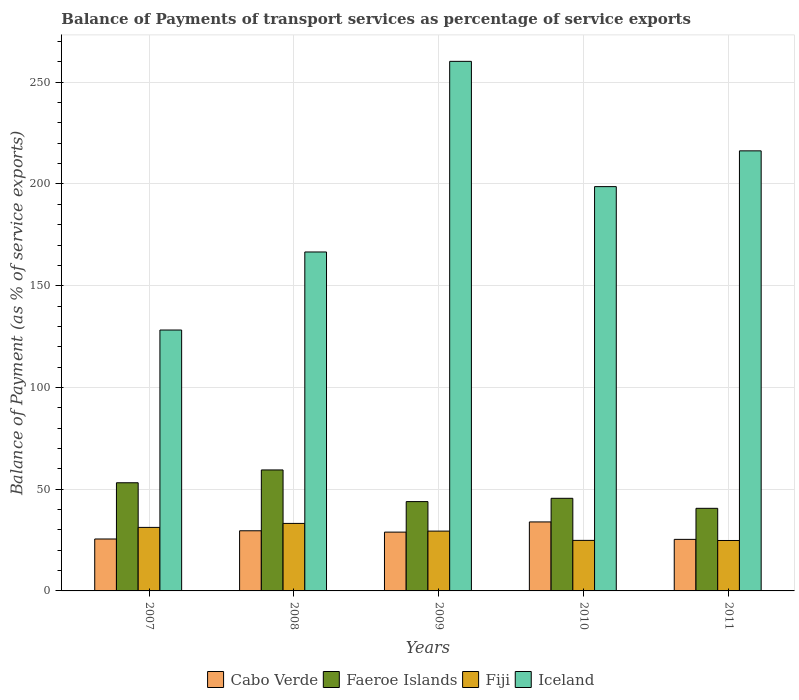How many groups of bars are there?
Offer a terse response. 5. Are the number of bars on each tick of the X-axis equal?
Offer a terse response. Yes. How many bars are there on the 1st tick from the right?
Offer a terse response. 4. What is the label of the 1st group of bars from the left?
Make the answer very short. 2007. What is the balance of payments of transport services in Fiji in 2010?
Offer a very short reply. 24.84. Across all years, what is the maximum balance of payments of transport services in Cabo Verde?
Offer a terse response. 33.91. Across all years, what is the minimum balance of payments of transport services in Cabo Verde?
Give a very brief answer. 25.34. In which year was the balance of payments of transport services in Cabo Verde maximum?
Provide a succinct answer. 2010. What is the total balance of payments of transport services in Faeroe Islands in the graph?
Ensure brevity in your answer.  242.63. What is the difference between the balance of payments of transport services in Fiji in 2008 and that in 2011?
Give a very brief answer. 8.39. What is the difference between the balance of payments of transport services in Cabo Verde in 2008 and the balance of payments of transport services in Fiji in 2010?
Provide a short and direct response. 4.72. What is the average balance of payments of transport services in Iceland per year?
Ensure brevity in your answer.  194.01. In the year 2010, what is the difference between the balance of payments of transport services in Fiji and balance of payments of transport services in Cabo Verde?
Your answer should be compact. -9.07. In how many years, is the balance of payments of transport services in Cabo Verde greater than 180 %?
Your answer should be compact. 0. What is the ratio of the balance of payments of transport services in Cabo Verde in 2008 to that in 2009?
Your answer should be very brief. 1.02. Is the difference between the balance of payments of transport services in Fiji in 2007 and 2009 greater than the difference between the balance of payments of transport services in Cabo Verde in 2007 and 2009?
Offer a terse response. Yes. What is the difference between the highest and the second highest balance of payments of transport services in Iceland?
Your answer should be compact. 43.99. What is the difference between the highest and the lowest balance of payments of transport services in Faeroe Islands?
Offer a terse response. 18.86. Is it the case that in every year, the sum of the balance of payments of transport services in Iceland and balance of payments of transport services in Fiji is greater than the sum of balance of payments of transport services in Faeroe Islands and balance of payments of transport services in Cabo Verde?
Your answer should be compact. Yes. What does the 3rd bar from the left in 2010 represents?
Ensure brevity in your answer.  Fiji. What does the 1st bar from the right in 2007 represents?
Your answer should be compact. Iceland. How many bars are there?
Give a very brief answer. 20. Are all the bars in the graph horizontal?
Give a very brief answer. No. How many years are there in the graph?
Provide a short and direct response. 5. Where does the legend appear in the graph?
Provide a short and direct response. Bottom center. What is the title of the graph?
Make the answer very short. Balance of Payments of transport services as percentage of service exports. What is the label or title of the X-axis?
Provide a succinct answer. Years. What is the label or title of the Y-axis?
Make the answer very short. Balance of Payment (as % of service exports). What is the Balance of Payment (as % of service exports) of Cabo Verde in 2007?
Your answer should be very brief. 25.53. What is the Balance of Payment (as % of service exports) in Faeroe Islands in 2007?
Provide a short and direct response. 53.16. What is the Balance of Payment (as % of service exports) in Fiji in 2007?
Offer a very short reply. 31.22. What is the Balance of Payment (as % of service exports) in Iceland in 2007?
Offer a very short reply. 128.23. What is the Balance of Payment (as % of service exports) of Cabo Verde in 2008?
Keep it short and to the point. 29.56. What is the Balance of Payment (as % of service exports) of Faeroe Islands in 2008?
Offer a terse response. 59.46. What is the Balance of Payment (as % of service exports) of Fiji in 2008?
Keep it short and to the point. 33.18. What is the Balance of Payment (as % of service exports) of Iceland in 2008?
Keep it short and to the point. 166.58. What is the Balance of Payment (as % of service exports) of Cabo Verde in 2009?
Make the answer very short. 28.9. What is the Balance of Payment (as % of service exports) in Faeroe Islands in 2009?
Your answer should be compact. 43.9. What is the Balance of Payment (as % of service exports) in Fiji in 2009?
Your answer should be very brief. 29.4. What is the Balance of Payment (as % of service exports) of Iceland in 2009?
Make the answer very short. 260.27. What is the Balance of Payment (as % of service exports) in Cabo Verde in 2010?
Your response must be concise. 33.91. What is the Balance of Payment (as % of service exports) of Faeroe Islands in 2010?
Keep it short and to the point. 45.52. What is the Balance of Payment (as % of service exports) of Fiji in 2010?
Your answer should be compact. 24.84. What is the Balance of Payment (as % of service exports) in Iceland in 2010?
Give a very brief answer. 198.71. What is the Balance of Payment (as % of service exports) in Cabo Verde in 2011?
Offer a terse response. 25.34. What is the Balance of Payment (as % of service exports) in Faeroe Islands in 2011?
Ensure brevity in your answer.  40.59. What is the Balance of Payment (as % of service exports) of Fiji in 2011?
Give a very brief answer. 24.79. What is the Balance of Payment (as % of service exports) of Iceland in 2011?
Provide a succinct answer. 216.28. Across all years, what is the maximum Balance of Payment (as % of service exports) of Cabo Verde?
Provide a short and direct response. 33.91. Across all years, what is the maximum Balance of Payment (as % of service exports) in Faeroe Islands?
Make the answer very short. 59.46. Across all years, what is the maximum Balance of Payment (as % of service exports) of Fiji?
Give a very brief answer. 33.18. Across all years, what is the maximum Balance of Payment (as % of service exports) in Iceland?
Ensure brevity in your answer.  260.27. Across all years, what is the minimum Balance of Payment (as % of service exports) in Cabo Verde?
Your answer should be compact. 25.34. Across all years, what is the minimum Balance of Payment (as % of service exports) in Faeroe Islands?
Ensure brevity in your answer.  40.59. Across all years, what is the minimum Balance of Payment (as % of service exports) of Fiji?
Give a very brief answer. 24.79. Across all years, what is the minimum Balance of Payment (as % of service exports) of Iceland?
Provide a succinct answer. 128.23. What is the total Balance of Payment (as % of service exports) of Cabo Verde in the graph?
Offer a very short reply. 143.24. What is the total Balance of Payment (as % of service exports) in Faeroe Islands in the graph?
Ensure brevity in your answer.  242.63. What is the total Balance of Payment (as % of service exports) of Fiji in the graph?
Your response must be concise. 143.42. What is the total Balance of Payment (as % of service exports) in Iceland in the graph?
Make the answer very short. 970.07. What is the difference between the Balance of Payment (as % of service exports) in Cabo Verde in 2007 and that in 2008?
Ensure brevity in your answer.  -4.03. What is the difference between the Balance of Payment (as % of service exports) in Faeroe Islands in 2007 and that in 2008?
Give a very brief answer. -6.3. What is the difference between the Balance of Payment (as % of service exports) of Fiji in 2007 and that in 2008?
Your response must be concise. -1.95. What is the difference between the Balance of Payment (as % of service exports) of Iceland in 2007 and that in 2008?
Keep it short and to the point. -38.35. What is the difference between the Balance of Payment (as % of service exports) in Cabo Verde in 2007 and that in 2009?
Your response must be concise. -3.38. What is the difference between the Balance of Payment (as % of service exports) in Faeroe Islands in 2007 and that in 2009?
Ensure brevity in your answer.  9.26. What is the difference between the Balance of Payment (as % of service exports) in Fiji in 2007 and that in 2009?
Provide a short and direct response. 1.82. What is the difference between the Balance of Payment (as % of service exports) in Iceland in 2007 and that in 2009?
Keep it short and to the point. -132.04. What is the difference between the Balance of Payment (as % of service exports) of Cabo Verde in 2007 and that in 2010?
Make the answer very short. -8.38. What is the difference between the Balance of Payment (as % of service exports) in Faeroe Islands in 2007 and that in 2010?
Keep it short and to the point. 7.64. What is the difference between the Balance of Payment (as % of service exports) in Fiji in 2007 and that in 2010?
Make the answer very short. 6.39. What is the difference between the Balance of Payment (as % of service exports) in Iceland in 2007 and that in 2010?
Make the answer very short. -70.48. What is the difference between the Balance of Payment (as % of service exports) in Cabo Verde in 2007 and that in 2011?
Offer a terse response. 0.18. What is the difference between the Balance of Payment (as % of service exports) in Faeroe Islands in 2007 and that in 2011?
Provide a succinct answer. 12.57. What is the difference between the Balance of Payment (as % of service exports) of Fiji in 2007 and that in 2011?
Your answer should be very brief. 6.44. What is the difference between the Balance of Payment (as % of service exports) of Iceland in 2007 and that in 2011?
Your answer should be very brief. -88.05. What is the difference between the Balance of Payment (as % of service exports) of Cabo Verde in 2008 and that in 2009?
Keep it short and to the point. 0.66. What is the difference between the Balance of Payment (as % of service exports) of Faeroe Islands in 2008 and that in 2009?
Give a very brief answer. 15.56. What is the difference between the Balance of Payment (as % of service exports) of Fiji in 2008 and that in 2009?
Give a very brief answer. 3.77. What is the difference between the Balance of Payment (as % of service exports) of Iceland in 2008 and that in 2009?
Provide a short and direct response. -93.69. What is the difference between the Balance of Payment (as % of service exports) in Cabo Verde in 2008 and that in 2010?
Keep it short and to the point. -4.35. What is the difference between the Balance of Payment (as % of service exports) of Faeroe Islands in 2008 and that in 2010?
Make the answer very short. 13.94. What is the difference between the Balance of Payment (as % of service exports) in Fiji in 2008 and that in 2010?
Offer a very short reply. 8.34. What is the difference between the Balance of Payment (as % of service exports) in Iceland in 2008 and that in 2010?
Your response must be concise. -32.13. What is the difference between the Balance of Payment (as % of service exports) in Cabo Verde in 2008 and that in 2011?
Ensure brevity in your answer.  4.22. What is the difference between the Balance of Payment (as % of service exports) of Faeroe Islands in 2008 and that in 2011?
Your answer should be very brief. 18.86. What is the difference between the Balance of Payment (as % of service exports) in Fiji in 2008 and that in 2011?
Make the answer very short. 8.39. What is the difference between the Balance of Payment (as % of service exports) of Iceland in 2008 and that in 2011?
Give a very brief answer. -49.7. What is the difference between the Balance of Payment (as % of service exports) of Cabo Verde in 2009 and that in 2010?
Keep it short and to the point. -5.01. What is the difference between the Balance of Payment (as % of service exports) of Faeroe Islands in 2009 and that in 2010?
Your response must be concise. -1.62. What is the difference between the Balance of Payment (as % of service exports) in Fiji in 2009 and that in 2010?
Your answer should be very brief. 4.57. What is the difference between the Balance of Payment (as % of service exports) in Iceland in 2009 and that in 2010?
Offer a terse response. 61.56. What is the difference between the Balance of Payment (as % of service exports) in Cabo Verde in 2009 and that in 2011?
Your answer should be compact. 3.56. What is the difference between the Balance of Payment (as % of service exports) in Faeroe Islands in 2009 and that in 2011?
Your response must be concise. 3.31. What is the difference between the Balance of Payment (as % of service exports) in Fiji in 2009 and that in 2011?
Offer a terse response. 4.62. What is the difference between the Balance of Payment (as % of service exports) of Iceland in 2009 and that in 2011?
Offer a terse response. 43.99. What is the difference between the Balance of Payment (as % of service exports) in Cabo Verde in 2010 and that in 2011?
Provide a succinct answer. 8.57. What is the difference between the Balance of Payment (as % of service exports) of Faeroe Islands in 2010 and that in 2011?
Provide a succinct answer. 4.92. What is the difference between the Balance of Payment (as % of service exports) in Fiji in 2010 and that in 2011?
Give a very brief answer. 0.05. What is the difference between the Balance of Payment (as % of service exports) in Iceland in 2010 and that in 2011?
Make the answer very short. -17.57. What is the difference between the Balance of Payment (as % of service exports) in Cabo Verde in 2007 and the Balance of Payment (as % of service exports) in Faeroe Islands in 2008?
Your response must be concise. -33.93. What is the difference between the Balance of Payment (as % of service exports) in Cabo Verde in 2007 and the Balance of Payment (as % of service exports) in Fiji in 2008?
Your answer should be very brief. -7.65. What is the difference between the Balance of Payment (as % of service exports) of Cabo Verde in 2007 and the Balance of Payment (as % of service exports) of Iceland in 2008?
Offer a very short reply. -141.06. What is the difference between the Balance of Payment (as % of service exports) in Faeroe Islands in 2007 and the Balance of Payment (as % of service exports) in Fiji in 2008?
Give a very brief answer. 19.98. What is the difference between the Balance of Payment (as % of service exports) of Faeroe Islands in 2007 and the Balance of Payment (as % of service exports) of Iceland in 2008?
Your answer should be very brief. -113.42. What is the difference between the Balance of Payment (as % of service exports) in Fiji in 2007 and the Balance of Payment (as % of service exports) in Iceland in 2008?
Make the answer very short. -135.36. What is the difference between the Balance of Payment (as % of service exports) in Cabo Verde in 2007 and the Balance of Payment (as % of service exports) in Faeroe Islands in 2009?
Offer a terse response. -18.38. What is the difference between the Balance of Payment (as % of service exports) in Cabo Verde in 2007 and the Balance of Payment (as % of service exports) in Fiji in 2009?
Make the answer very short. -3.88. What is the difference between the Balance of Payment (as % of service exports) in Cabo Verde in 2007 and the Balance of Payment (as % of service exports) in Iceland in 2009?
Make the answer very short. -234.74. What is the difference between the Balance of Payment (as % of service exports) in Faeroe Islands in 2007 and the Balance of Payment (as % of service exports) in Fiji in 2009?
Your response must be concise. 23.76. What is the difference between the Balance of Payment (as % of service exports) of Faeroe Islands in 2007 and the Balance of Payment (as % of service exports) of Iceland in 2009?
Ensure brevity in your answer.  -207.11. What is the difference between the Balance of Payment (as % of service exports) in Fiji in 2007 and the Balance of Payment (as % of service exports) in Iceland in 2009?
Give a very brief answer. -229.05. What is the difference between the Balance of Payment (as % of service exports) in Cabo Verde in 2007 and the Balance of Payment (as % of service exports) in Faeroe Islands in 2010?
Offer a very short reply. -19.99. What is the difference between the Balance of Payment (as % of service exports) in Cabo Verde in 2007 and the Balance of Payment (as % of service exports) in Fiji in 2010?
Keep it short and to the point. 0.69. What is the difference between the Balance of Payment (as % of service exports) of Cabo Verde in 2007 and the Balance of Payment (as % of service exports) of Iceland in 2010?
Make the answer very short. -173.18. What is the difference between the Balance of Payment (as % of service exports) in Faeroe Islands in 2007 and the Balance of Payment (as % of service exports) in Fiji in 2010?
Keep it short and to the point. 28.32. What is the difference between the Balance of Payment (as % of service exports) of Faeroe Islands in 2007 and the Balance of Payment (as % of service exports) of Iceland in 2010?
Ensure brevity in your answer.  -145.55. What is the difference between the Balance of Payment (as % of service exports) in Fiji in 2007 and the Balance of Payment (as % of service exports) in Iceland in 2010?
Your response must be concise. -167.48. What is the difference between the Balance of Payment (as % of service exports) in Cabo Verde in 2007 and the Balance of Payment (as % of service exports) in Faeroe Islands in 2011?
Make the answer very short. -15.07. What is the difference between the Balance of Payment (as % of service exports) in Cabo Verde in 2007 and the Balance of Payment (as % of service exports) in Fiji in 2011?
Your answer should be compact. 0.74. What is the difference between the Balance of Payment (as % of service exports) of Cabo Verde in 2007 and the Balance of Payment (as % of service exports) of Iceland in 2011?
Provide a short and direct response. -190.76. What is the difference between the Balance of Payment (as % of service exports) of Faeroe Islands in 2007 and the Balance of Payment (as % of service exports) of Fiji in 2011?
Give a very brief answer. 28.37. What is the difference between the Balance of Payment (as % of service exports) of Faeroe Islands in 2007 and the Balance of Payment (as % of service exports) of Iceland in 2011?
Keep it short and to the point. -163.12. What is the difference between the Balance of Payment (as % of service exports) of Fiji in 2007 and the Balance of Payment (as % of service exports) of Iceland in 2011?
Keep it short and to the point. -185.06. What is the difference between the Balance of Payment (as % of service exports) in Cabo Verde in 2008 and the Balance of Payment (as % of service exports) in Faeroe Islands in 2009?
Keep it short and to the point. -14.34. What is the difference between the Balance of Payment (as % of service exports) in Cabo Verde in 2008 and the Balance of Payment (as % of service exports) in Fiji in 2009?
Offer a very short reply. 0.16. What is the difference between the Balance of Payment (as % of service exports) in Cabo Verde in 2008 and the Balance of Payment (as % of service exports) in Iceland in 2009?
Your answer should be very brief. -230.71. What is the difference between the Balance of Payment (as % of service exports) of Faeroe Islands in 2008 and the Balance of Payment (as % of service exports) of Fiji in 2009?
Your answer should be compact. 30.05. What is the difference between the Balance of Payment (as % of service exports) of Faeroe Islands in 2008 and the Balance of Payment (as % of service exports) of Iceland in 2009?
Your answer should be compact. -200.81. What is the difference between the Balance of Payment (as % of service exports) in Fiji in 2008 and the Balance of Payment (as % of service exports) in Iceland in 2009?
Offer a very short reply. -227.09. What is the difference between the Balance of Payment (as % of service exports) of Cabo Verde in 2008 and the Balance of Payment (as % of service exports) of Faeroe Islands in 2010?
Keep it short and to the point. -15.96. What is the difference between the Balance of Payment (as % of service exports) in Cabo Verde in 2008 and the Balance of Payment (as % of service exports) in Fiji in 2010?
Keep it short and to the point. 4.72. What is the difference between the Balance of Payment (as % of service exports) of Cabo Verde in 2008 and the Balance of Payment (as % of service exports) of Iceland in 2010?
Provide a succinct answer. -169.15. What is the difference between the Balance of Payment (as % of service exports) in Faeroe Islands in 2008 and the Balance of Payment (as % of service exports) in Fiji in 2010?
Your response must be concise. 34.62. What is the difference between the Balance of Payment (as % of service exports) in Faeroe Islands in 2008 and the Balance of Payment (as % of service exports) in Iceland in 2010?
Provide a short and direct response. -139.25. What is the difference between the Balance of Payment (as % of service exports) of Fiji in 2008 and the Balance of Payment (as % of service exports) of Iceland in 2010?
Ensure brevity in your answer.  -165.53. What is the difference between the Balance of Payment (as % of service exports) in Cabo Verde in 2008 and the Balance of Payment (as % of service exports) in Faeroe Islands in 2011?
Offer a terse response. -11.04. What is the difference between the Balance of Payment (as % of service exports) in Cabo Verde in 2008 and the Balance of Payment (as % of service exports) in Fiji in 2011?
Your answer should be compact. 4.77. What is the difference between the Balance of Payment (as % of service exports) of Cabo Verde in 2008 and the Balance of Payment (as % of service exports) of Iceland in 2011?
Make the answer very short. -186.72. What is the difference between the Balance of Payment (as % of service exports) in Faeroe Islands in 2008 and the Balance of Payment (as % of service exports) in Fiji in 2011?
Offer a terse response. 34.67. What is the difference between the Balance of Payment (as % of service exports) of Faeroe Islands in 2008 and the Balance of Payment (as % of service exports) of Iceland in 2011?
Your answer should be compact. -156.82. What is the difference between the Balance of Payment (as % of service exports) in Fiji in 2008 and the Balance of Payment (as % of service exports) in Iceland in 2011?
Offer a terse response. -183.11. What is the difference between the Balance of Payment (as % of service exports) in Cabo Verde in 2009 and the Balance of Payment (as % of service exports) in Faeroe Islands in 2010?
Your answer should be very brief. -16.62. What is the difference between the Balance of Payment (as % of service exports) of Cabo Verde in 2009 and the Balance of Payment (as % of service exports) of Fiji in 2010?
Offer a very short reply. 4.07. What is the difference between the Balance of Payment (as % of service exports) of Cabo Verde in 2009 and the Balance of Payment (as % of service exports) of Iceland in 2010?
Your response must be concise. -169.81. What is the difference between the Balance of Payment (as % of service exports) of Faeroe Islands in 2009 and the Balance of Payment (as % of service exports) of Fiji in 2010?
Ensure brevity in your answer.  19.06. What is the difference between the Balance of Payment (as % of service exports) of Faeroe Islands in 2009 and the Balance of Payment (as % of service exports) of Iceland in 2010?
Make the answer very short. -154.81. What is the difference between the Balance of Payment (as % of service exports) of Fiji in 2009 and the Balance of Payment (as % of service exports) of Iceland in 2010?
Make the answer very short. -169.3. What is the difference between the Balance of Payment (as % of service exports) in Cabo Verde in 2009 and the Balance of Payment (as % of service exports) in Faeroe Islands in 2011?
Your answer should be compact. -11.69. What is the difference between the Balance of Payment (as % of service exports) in Cabo Verde in 2009 and the Balance of Payment (as % of service exports) in Fiji in 2011?
Keep it short and to the point. 4.12. What is the difference between the Balance of Payment (as % of service exports) in Cabo Verde in 2009 and the Balance of Payment (as % of service exports) in Iceland in 2011?
Make the answer very short. -187.38. What is the difference between the Balance of Payment (as % of service exports) in Faeroe Islands in 2009 and the Balance of Payment (as % of service exports) in Fiji in 2011?
Provide a succinct answer. 19.11. What is the difference between the Balance of Payment (as % of service exports) of Faeroe Islands in 2009 and the Balance of Payment (as % of service exports) of Iceland in 2011?
Make the answer very short. -172.38. What is the difference between the Balance of Payment (as % of service exports) of Fiji in 2009 and the Balance of Payment (as % of service exports) of Iceland in 2011?
Keep it short and to the point. -186.88. What is the difference between the Balance of Payment (as % of service exports) of Cabo Verde in 2010 and the Balance of Payment (as % of service exports) of Faeroe Islands in 2011?
Give a very brief answer. -6.69. What is the difference between the Balance of Payment (as % of service exports) in Cabo Verde in 2010 and the Balance of Payment (as % of service exports) in Fiji in 2011?
Keep it short and to the point. 9.12. What is the difference between the Balance of Payment (as % of service exports) of Cabo Verde in 2010 and the Balance of Payment (as % of service exports) of Iceland in 2011?
Your answer should be compact. -182.37. What is the difference between the Balance of Payment (as % of service exports) of Faeroe Islands in 2010 and the Balance of Payment (as % of service exports) of Fiji in 2011?
Provide a succinct answer. 20.73. What is the difference between the Balance of Payment (as % of service exports) of Faeroe Islands in 2010 and the Balance of Payment (as % of service exports) of Iceland in 2011?
Your response must be concise. -170.76. What is the difference between the Balance of Payment (as % of service exports) in Fiji in 2010 and the Balance of Payment (as % of service exports) in Iceland in 2011?
Your answer should be compact. -191.44. What is the average Balance of Payment (as % of service exports) in Cabo Verde per year?
Your response must be concise. 28.65. What is the average Balance of Payment (as % of service exports) of Faeroe Islands per year?
Keep it short and to the point. 48.53. What is the average Balance of Payment (as % of service exports) in Fiji per year?
Keep it short and to the point. 28.68. What is the average Balance of Payment (as % of service exports) in Iceland per year?
Provide a short and direct response. 194.01. In the year 2007, what is the difference between the Balance of Payment (as % of service exports) in Cabo Verde and Balance of Payment (as % of service exports) in Faeroe Islands?
Your answer should be very brief. -27.64. In the year 2007, what is the difference between the Balance of Payment (as % of service exports) of Cabo Verde and Balance of Payment (as % of service exports) of Fiji?
Make the answer very short. -5.7. In the year 2007, what is the difference between the Balance of Payment (as % of service exports) of Cabo Verde and Balance of Payment (as % of service exports) of Iceland?
Make the answer very short. -102.7. In the year 2007, what is the difference between the Balance of Payment (as % of service exports) in Faeroe Islands and Balance of Payment (as % of service exports) in Fiji?
Give a very brief answer. 21.94. In the year 2007, what is the difference between the Balance of Payment (as % of service exports) of Faeroe Islands and Balance of Payment (as % of service exports) of Iceland?
Make the answer very short. -75.07. In the year 2007, what is the difference between the Balance of Payment (as % of service exports) in Fiji and Balance of Payment (as % of service exports) in Iceland?
Provide a succinct answer. -97. In the year 2008, what is the difference between the Balance of Payment (as % of service exports) in Cabo Verde and Balance of Payment (as % of service exports) in Faeroe Islands?
Provide a succinct answer. -29.9. In the year 2008, what is the difference between the Balance of Payment (as % of service exports) in Cabo Verde and Balance of Payment (as % of service exports) in Fiji?
Provide a short and direct response. -3.62. In the year 2008, what is the difference between the Balance of Payment (as % of service exports) in Cabo Verde and Balance of Payment (as % of service exports) in Iceland?
Make the answer very short. -137.02. In the year 2008, what is the difference between the Balance of Payment (as % of service exports) in Faeroe Islands and Balance of Payment (as % of service exports) in Fiji?
Offer a very short reply. 26.28. In the year 2008, what is the difference between the Balance of Payment (as % of service exports) in Faeroe Islands and Balance of Payment (as % of service exports) in Iceland?
Provide a short and direct response. -107.12. In the year 2008, what is the difference between the Balance of Payment (as % of service exports) in Fiji and Balance of Payment (as % of service exports) in Iceland?
Provide a succinct answer. -133.41. In the year 2009, what is the difference between the Balance of Payment (as % of service exports) in Cabo Verde and Balance of Payment (as % of service exports) in Faeroe Islands?
Ensure brevity in your answer.  -15. In the year 2009, what is the difference between the Balance of Payment (as % of service exports) in Cabo Verde and Balance of Payment (as % of service exports) in Fiji?
Keep it short and to the point. -0.5. In the year 2009, what is the difference between the Balance of Payment (as % of service exports) of Cabo Verde and Balance of Payment (as % of service exports) of Iceland?
Keep it short and to the point. -231.37. In the year 2009, what is the difference between the Balance of Payment (as % of service exports) of Faeroe Islands and Balance of Payment (as % of service exports) of Fiji?
Provide a short and direct response. 14.5. In the year 2009, what is the difference between the Balance of Payment (as % of service exports) in Faeroe Islands and Balance of Payment (as % of service exports) in Iceland?
Make the answer very short. -216.37. In the year 2009, what is the difference between the Balance of Payment (as % of service exports) in Fiji and Balance of Payment (as % of service exports) in Iceland?
Your answer should be very brief. -230.87. In the year 2010, what is the difference between the Balance of Payment (as % of service exports) in Cabo Verde and Balance of Payment (as % of service exports) in Faeroe Islands?
Your answer should be compact. -11.61. In the year 2010, what is the difference between the Balance of Payment (as % of service exports) of Cabo Verde and Balance of Payment (as % of service exports) of Fiji?
Keep it short and to the point. 9.07. In the year 2010, what is the difference between the Balance of Payment (as % of service exports) in Cabo Verde and Balance of Payment (as % of service exports) in Iceland?
Keep it short and to the point. -164.8. In the year 2010, what is the difference between the Balance of Payment (as % of service exports) of Faeroe Islands and Balance of Payment (as % of service exports) of Fiji?
Offer a very short reply. 20.68. In the year 2010, what is the difference between the Balance of Payment (as % of service exports) in Faeroe Islands and Balance of Payment (as % of service exports) in Iceland?
Make the answer very short. -153.19. In the year 2010, what is the difference between the Balance of Payment (as % of service exports) of Fiji and Balance of Payment (as % of service exports) of Iceland?
Offer a terse response. -173.87. In the year 2011, what is the difference between the Balance of Payment (as % of service exports) of Cabo Verde and Balance of Payment (as % of service exports) of Faeroe Islands?
Offer a terse response. -15.25. In the year 2011, what is the difference between the Balance of Payment (as % of service exports) of Cabo Verde and Balance of Payment (as % of service exports) of Fiji?
Your answer should be compact. 0.56. In the year 2011, what is the difference between the Balance of Payment (as % of service exports) in Cabo Verde and Balance of Payment (as % of service exports) in Iceland?
Provide a short and direct response. -190.94. In the year 2011, what is the difference between the Balance of Payment (as % of service exports) in Faeroe Islands and Balance of Payment (as % of service exports) in Fiji?
Keep it short and to the point. 15.81. In the year 2011, what is the difference between the Balance of Payment (as % of service exports) of Faeroe Islands and Balance of Payment (as % of service exports) of Iceland?
Offer a very short reply. -175.69. In the year 2011, what is the difference between the Balance of Payment (as % of service exports) of Fiji and Balance of Payment (as % of service exports) of Iceland?
Provide a succinct answer. -191.49. What is the ratio of the Balance of Payment (as % of service exports) in Cabo Verde in 2007 to that in 2008?
Provide a succinct answer. 0.86. What is the ratio of the Balance of Payment (as % of service exports) of Faeroe Islands in 2007 to that in 2008?
Offer a terse response. 0.89. What is the ratio of the Balance of Payment (as % of service exports) of Fiji in 2007 to that in 2008?
Your answer should be very brief. 0.94. What is the ratio of the Balance of Payment (as % of service exports) in Iceland in 2007 to that in 2008?
Offer a very short reply. 0.77. What is the ratio of the Balance of Payment (as % of service exports) in Cabo Verde in 2007 to that in 2009?
Give a very brief answer. 0.88. What is the ratio of the Balance of Payment (as % of service exports) of Faeroe Islands in 2007 to that in 2009?
Offer a very short reply. 1.21. What is the ratio of the Balance of Payment (as % of service exports) in Fiji in 2007 to that in 2009?
Provide a succinct answer. 1.06. What is the ratio of the Balance of Payment (as % of service exports) in Iceland in 2007 to that in 2009?
Make the answer very short. 0.49. What is the ratio of the Balance of Payment (as % of service exports) in Cabo Verde in 2007 to that in 2010?
Keep it short and to the point. 0.75. What is the ratio of the Balance of Payment (as % of service exports) in Faeroe Islands in 2007 to that in 2010?
Give a very brief answer. 1.17. What is the ratio of the Balance of Payment (as % of service exports) in Fiji in 2007 to that in 2010?
Your response must be concise. 1.26. What is the ratio of the Balance of Payment (as % of service exports) of Iceland in 2007 to that in 2010?
Your response must be concise. 0.65. What is the ratio of the Balance of Payment (as % of service exports) in Cabo Verde in 2007 to that in 2011?
Provide a short and direct response. 1.01. What is the ratio of the Balance of Payment (as % of service exports) in Faeroe Islands in 2007 to that in 2011?
Your response must be concise. 1.31. What is the ratio of the Balance of Payment (as % of service exports) in Fiji in 2007 to that in 2011?
Provide a short and direct response. 1.26. What is the ratio of the Balance of Payment (as % of service exports) of Iceland in 2007 to that in 2011?
Offer a very short reply. 0.59. What is the ratio of the Balance of Payment (as % of service exports) in Cabo Verde in 2008 to that in 2009?
Provide a succinct answer. 1.02. What is the ratio of the Balance of Payment (as % of service exports) of Faeroe Islands in 2008 to that in 2009?
Your answer should be compact. 1.35. What is the ratio of the Balance of Payment (as % of service exports) of Fiji in 2008 to that in 2009?
Make the answer very short. 1.13. What is the ratio of the Balance of Payment (as % of service exports) in Iceland in 2008 to that in 2009?
Your answer should be very brief. 0.64. What is the ratio of the Balance of Payment (as % of service exports) in Cabo Verde in 2008 to that in 2010?
Offer a terse response. 0.87. What is the ratio of the Balance of Payment (as % of service exports) of Faeroe Islands in 2008 to that in 2010?
Make the answer very short. 1.31. What is the ratio of the Balance of Payment (as % of service exports) of Fiji in 2008 to that in 2010?
Your answer should be very brief. 1.34. What is the ratio of the Balance of Payment (as % of service exports) in Iceland in 2008 to that in 2010?
Give a very brief answer. 0.84. What is the ratio of the Balance of Payment (as % of service exports) of Cabo Verde in 2008 to that in 2011?
Offer a very short reply. 1.17. What is the ratio of the Balance of Payment (as % of service exports) in Faeroe Islands in 2008 to that in 2011?
Your answer should be very brief. 1.46. What is the ratio of the Balance of Payment (as % of service exports) of Fiji in 2008 to that in 2011?
Offer a very short reply. 1.34. What is the ratio of the Balance of Payment (as % of service exports) of Iceland in 2008 to that in 2011?
Offer a terse response. 0.77. What is the ratio of the Balance of Payment (as % of service exports) in Cabo Verde in 2009 to that in 2010?
Your answer should be very brief. 0.85. What is the ratio of the Balance of Payment (as % of service exports) in Faeroe Islands in 2009 to that in 2010?
Ensure brevity in your answer.  0.96. What is the ratio of the Balance of Payment (as % of service exports) of Fiji in 2009 to that in 2010?
Give a very brief answer. 1.18. What is the ratio of the Balance of Payment (as % of service exports) of Iceland in 2009 to that in 2010?
Your answer should be very brief. 1.31. What is the ratio of the Balance of Payment (as % of service exports) of Cabo Verde in 2009 to that in 2011?
Provide a short and direct response. 1.14. What is the ratio of the Balance of Payment (as % of service exports) of Faeroe Islands in 2009 to that in 2011?
Provide a short and direct response. 1.08. What is the ratio of the Balance of Payment (as % of service exports) in Fiji in 2009 to that in 2011?
Make the answer very short. 1.19. What is the ratio of the Balance of Payment (as % of service exports) in Iceland in 2009 to that in 2011?
Ensure brevity in your answer.  1.2. What is the ratio of the Balance of Payment (as % of service exports) of Cabo Verde in 2010 to that in 2011?
Provide a short and direct response. 1.34. What is the ratio of the Balance of Payment (as % of service exports) in Faeroe Islands in 2010 to that in 2011?
Offer a terse response. 1.12. What is the ratio of the Balance of Payment (as % of service exports) of Iceland in 2010 to that in 2011?
Give a very brief answer. 0.92. What is the difference between the highest and the second highest Balance of Payment (as % of service exports) in Cabo Verde?
Offer a terse response. 4.35. What is the difference between the highest and the second highest Balance of Payment (as % of service exports) in Faeroe Islands?
Provide a short and direct response. 6.3. What is the difference between the highest and the second highest Balance of Payment (as % of service exports) in Fiji?
Your answer should be very brief. 1.95. What is the difference between the highest and the second highest Balance of Payment (as % of service exports) of Iceland?
Your response must be concise. 43.99. What is the difference between the highest and the lowest Balance of Payment (as % of service exports) of Cabo Verde?
Your answer should be compact. 8.57. What is the difference between the highest and the lowest Balance of Payment (as % of service exports) of Faeroe Islands?
Your answer should be very brief. 18.86. What is the difference between the highest and the lowest Balance of Payment (as % of service exports) of Fiji?
Offer a very short reply. 8.39. What is the difference between the highest and the lowest Balance of Payment (as % of service exports) in Iceland?
Make the answer very short. 132.04. 